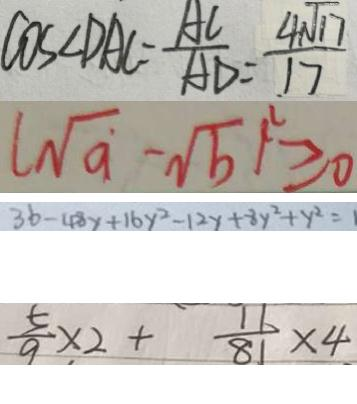<formula> <loc_0><loc_0><loc_500><loc_500>\cos \angle D A C = \frac { A C } { A D } = \frac { 4 \sqrt { 1 7 } } { 1 7 } 
 ( \sqrt { a } - \sqrt { b } ) ^ { 2 } \geq 0 
 3 b - 4 8 y + 1 6 y ^ { 2 } - 1 2 y + 8 y ^ { 2 } + y ^ { 2 } = 1 
 \frac { 5 } { 9 } \times 2 + \frac { 1 1 } { 8 1 } \times 4</formula> 